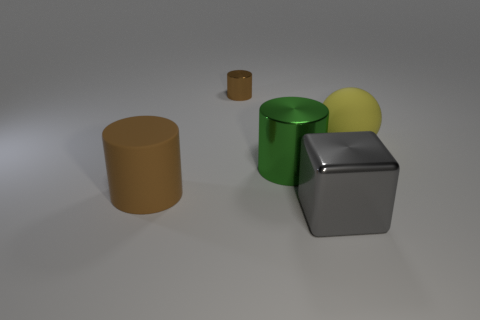Add 3 big purple rubber spheres. How many objects exist? 8 Subtract all cylinders. How many objects are left? 2 Add 4 big rubber cylinders. How many big rubber cylinders are left? 5 Add 3 small purple metallic things. How many small purple metallic things exist? 3 Subtract 1 gray blocks. How many objects are left? 4 Subtract all large cubes. Subtract all tiny purple objects. How many objects are left? 4 